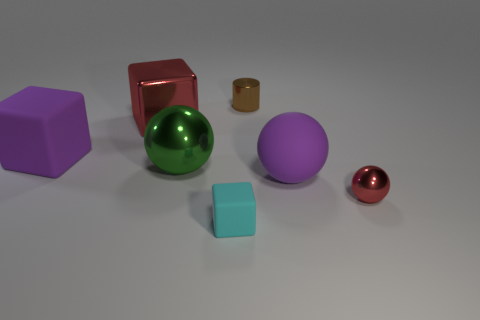Is there anything else that is the same shape as the tiny brown thing?
Your answer should be compact. No. There is a sphere that is the same color as the large shiny cube; what is its material?
Give a very brief answer. Metal. What number of things are small things behind the purple ball or tiny objects that are behind the large red block?
Your answer should be very brief. 1. Is the size of the shiny object that is on the right side of the brown thing the same as the purple thing that is behind the big purple ball?
Offer a very short reply. No. Are there any large shiny spheres that are in front of the large purple object on the right side of the tiny brown shiny object?
Provide a short and direct response. No. What number of big balls are to the right of the purple sphere?
Provide a succinct answer. 0. What number of other things are there of the same color as the large shiny sphere?
Give a very brief answer. 0. Is the number of rubber spheres on the left side of the big red metallic block less than the number of tiny metal cylinders on the left side of the tiny cyan object?
Keep it short and to the point. No. What number of things are either red metal objects that are to the right of the green metallic object or large red metallic objects?
Offer a very short reply. 2. Do the brown metallic cylinder and the purple thing that is right of the large red metallic thing have the same size?
Provide a short and direct response. No. 